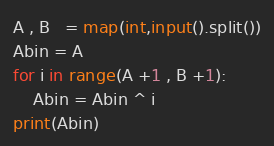<code> <loc_0><loc_0><loc_500><loc_500><_Python_>A , B   = map(int,input().split())
Abin = A
for i in range(A +1 , B +1):
    Abin = Abin ^ i
print(Abin)</code> 